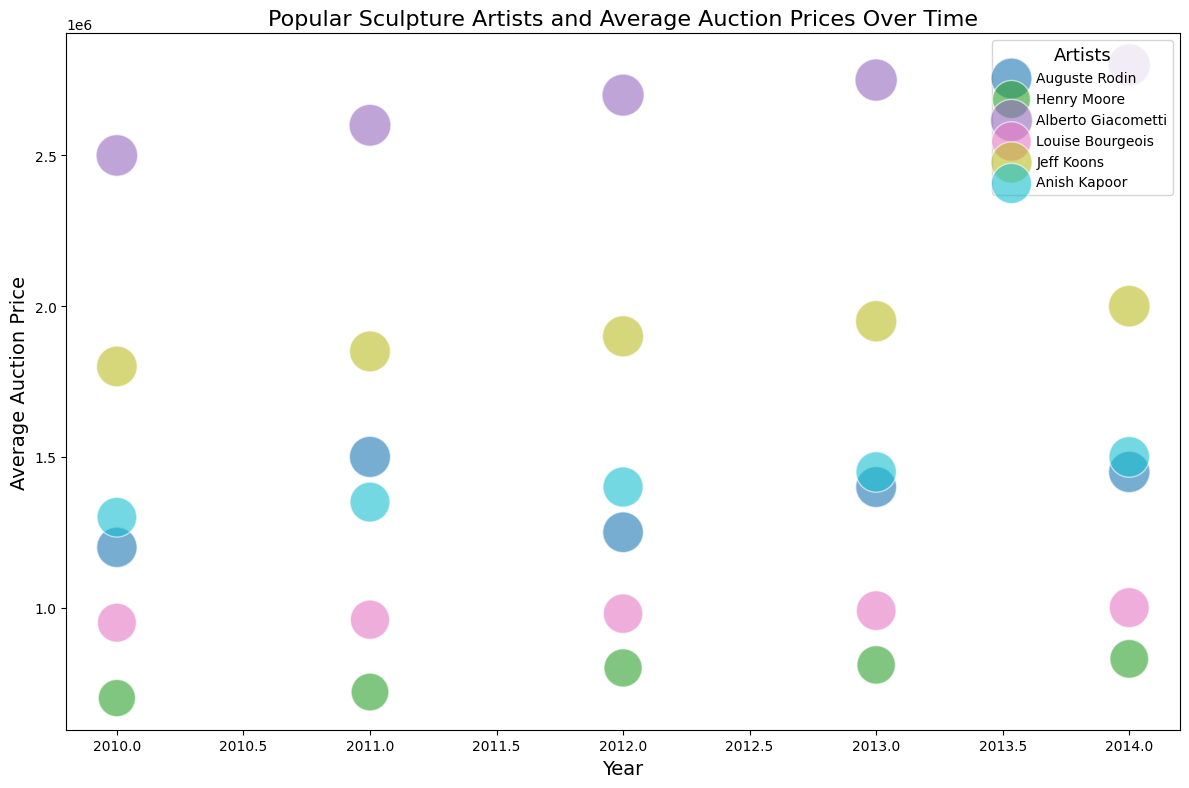Which artist had the highest average auction price in 2014? Find the bubbles along the x-axis point labeled 2014 and identify the artist with the highest bubble on the y-axis.
Answer: Alberto Giacometti Which artist shows a continuous increase in the average auction price from 2010 to 2014? Look for the artist whose bubbles increase steadily upwards along the y-axis from 2010 to 2014.
Answer: Louise Bourgeois What is the difference between the highest and lowest average auction prices in 2013? Identify the highest and lowest bubbles along the 2013 x-axis point and subtract the two y-axis values.
Answer: 1,750,000 Among the listed artists, who generally appears to have the smallest bubble sizes? Compare the sizes of bubbles visually for each artist.
Answer: Henry Moore Between Auguste Rodin and Jeff Koons, who had a higher popularity score in 2012? Compare the bubble sizes of Auguste Rodin and Jeff Koons along the 2012 x-axis point.
Answer: Jeff Koons Which artist has the highest popularity score overall? Identify the artist with the largest bubble in the entire chart.
Answer: Alberto Giacometti In which year did Anish Kapoor experience the largest average auction price increase compared to the previous year? Check Anish Kapoor's bubble positions vertically and identify the year where the increase in the y-axis (price) is the highest compared to the previous year.
Answer: 2011 How does Henry Moore's average auction price in 2014 compare to Jeff Koons' in the same year? Compare the position of Henry Moore's and Jeff Koons' bubbles along the 2014 x-axis point.
Answer: Lower Which year had the highest average auction price for Louise Bourgeois? Identify the year where Louise Bourgeois' bubble is highest on the y-axis.
Answer: 2014 